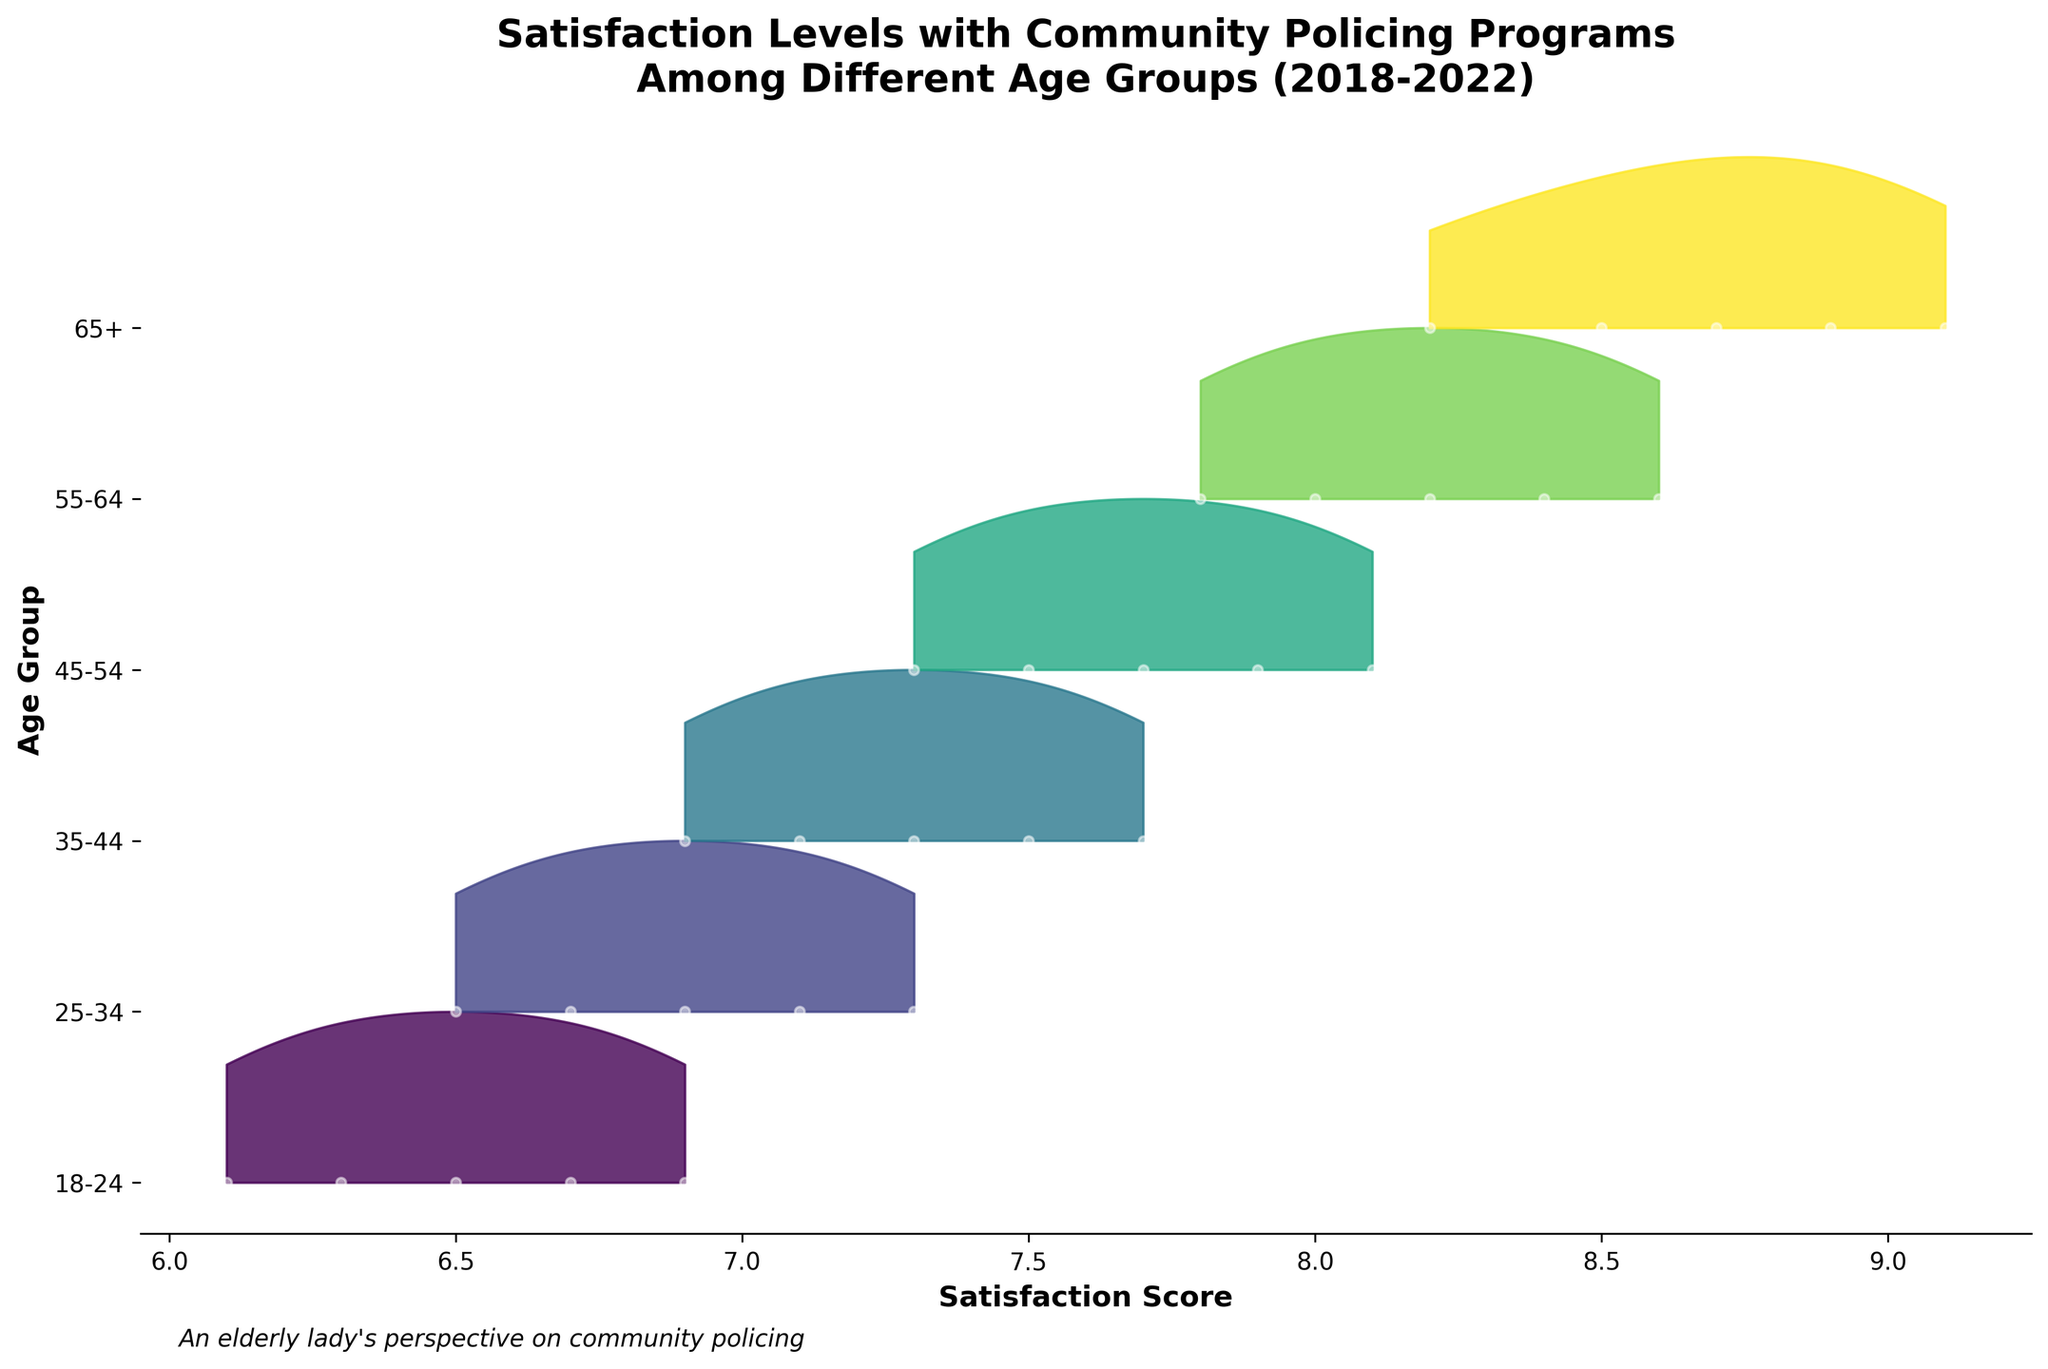What are the age groups covered by the plot? The plot covers different age groups from "65+" down to "18-24". This information is gathered from the y-axis labels.
Answer: "65+", "55-64", "45-54", "35-44", "25-34", "18-24" Which age group has the highest satisfaction score in 2022? In the plot, the satisfaction scores are indicated along the x-axis. The "65+" age group shows the highest satisfaction score in 2022 at 9.1, based on the data points marked on the plot.
Answer: 65+ What's the trend of satisfaction scores for the "35-44" age group over the years 2018 to 2022? The satisfaction scores for the "35-44" group are 6.9, 7.1, 7.3, 7.5, and 7.7, showing a consistent upward trend over the years. This can be identified by looking at the placement of the data points over the years.
Answer: Increasing Which age group shows the least satisfaction in 2018? In the plot, the "18-24" age group has the lowest satisfaction score in 2018, which is 6.1. This is determined by comparing the data points for 2018 across all age groups.
Answer: 18-24 How does the satisfaction score of "55-64" in 2021 compare to "25-34" in 2019? The satisfaction score of the "55-64" age group in 2021 is 8.4, whereas for "25-34" in 2019 it is 6.7. Hence, "55-64" in 2021 has a higher satisfaction score compared to "25-34" in 2019.
Answer: "55-64" in 2021 is higher What's the 5-year average satisfaction score for the "45-54" age group? The satisfaction scores for the "45-54" age group from 2018 to 2022 are 7.3, 7.5, 7.7, 7.9, and 8.1. Adding these together gives 38.5, and dividing by 5 results in an average of 7.7.
Answer: 7.7 Which year had the highest overall satisfaction scores across all age groups? By examining the plot, 2022 has consistently higher satisfaction scores in each age group compared to other years, indicating that 2022 had the highest overall satisfaction scores across all age groups.
Answer: 2022 Do younger age groups (18-24) show more or less satisfaction compared to older age groups (65+) in the same years? Younger age groups (18-24) consistently show lower satisfaction scores compared to older age groups (65+) in the same years from 2018 to 2022, as seen by comparing their respective data points for each year.
Answer: Less What's the difference in satisfaction scores between "25-34" in 2020 and "65+" in 2020? The satisfaction score for "25-34" in 2020 is 6.9, while for "65+" in the same year, it is 8.7. The difference is 8.7 - 6.9 = 1.8.
Answer: 1.8 